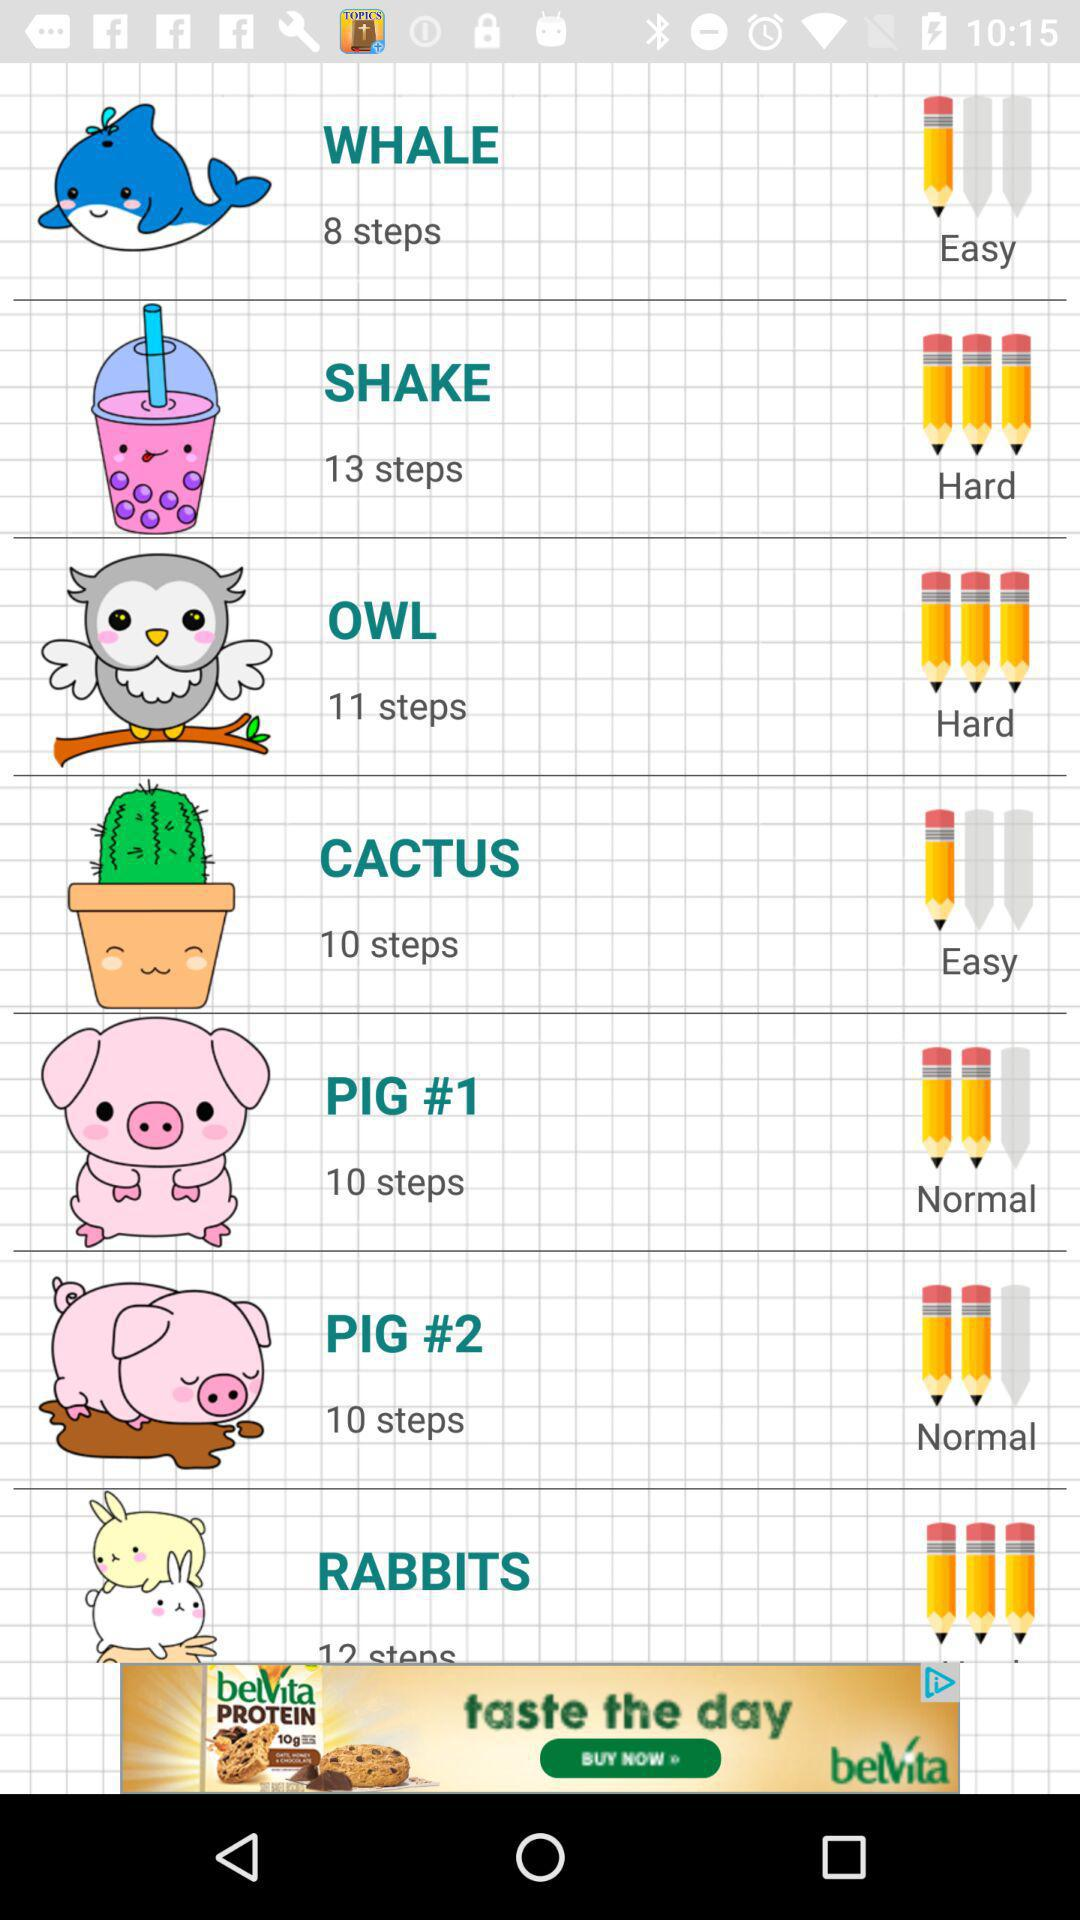How many steps are there in Cactus? There are 10 steps. 